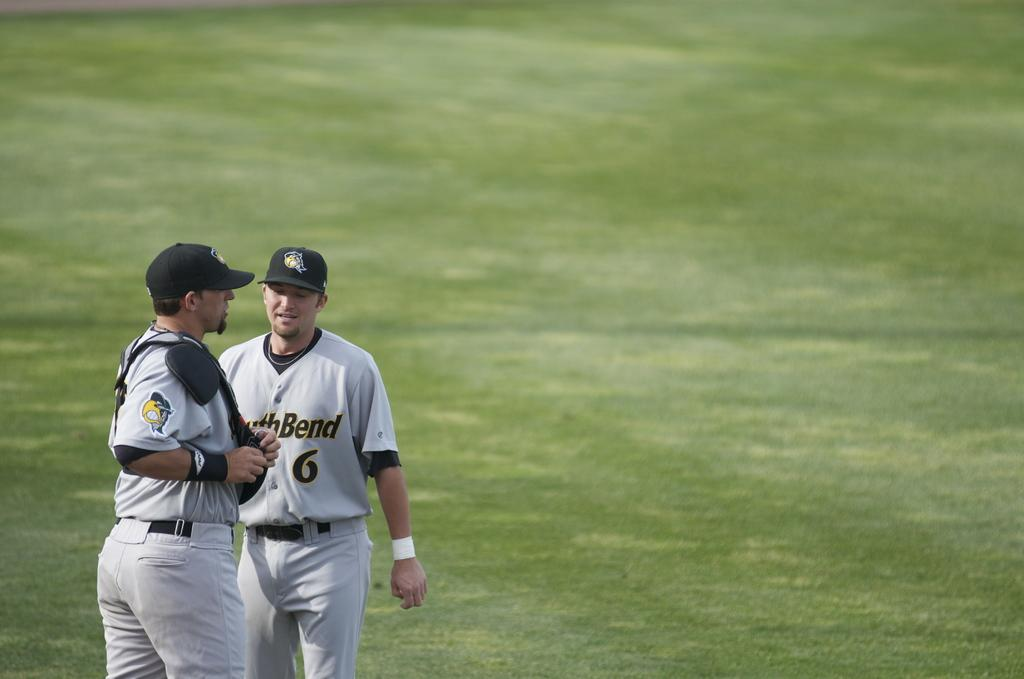<image>
Relay a brief, clear account of the picture shown. a couple players with one wearing the number 6 